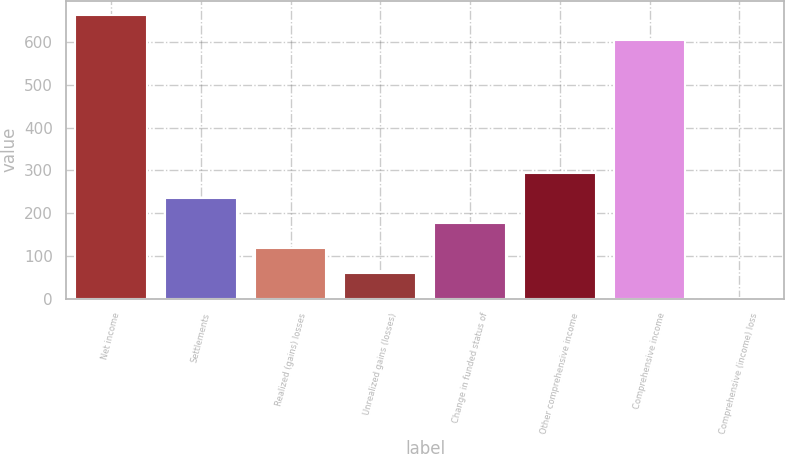Convert chart to OTSL. <chart><loc_0><loc_0><loc_500><loc_500><bar_chart><fcel>Net income<fcel>Settlements<fcel>Realized (gains) losses<fcel>Unrealized gains (losses)<fcel>Change in funded status of<fcel>Other comprehensive income<fcel>Comprehensive income<fcel>Comprehensive (income) loss<nl><fcel>663.22<fcel>235.74<fcel>118.02<fcel>59.16<fcel>176.88<fcel>294.6<fcel>604.36<fcel>0.3<nl></chart> 